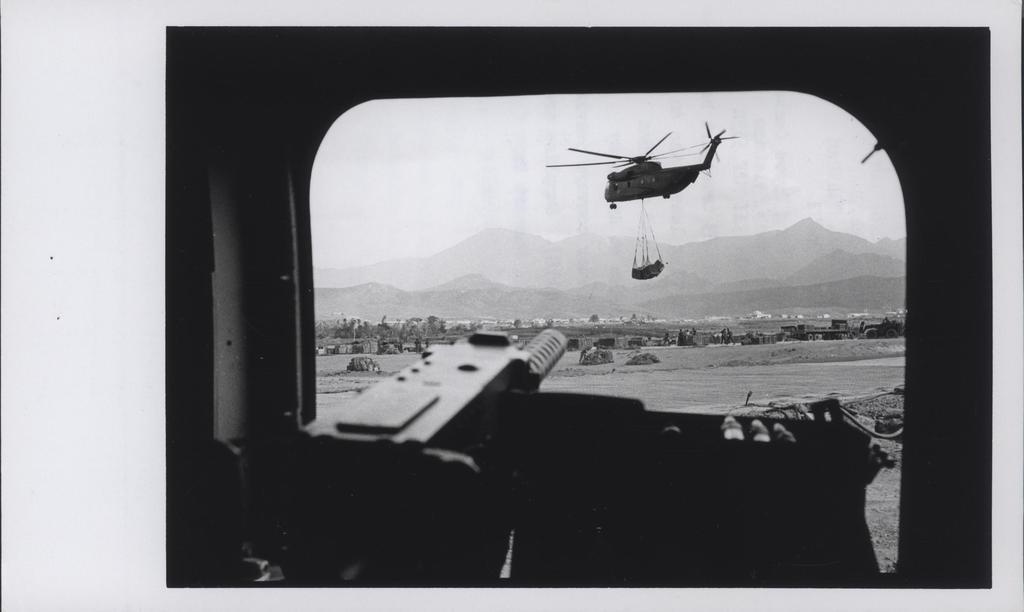Can you describe this image briefly? In this picture I can see a gun and in the background I can see a helicopter and hills and I can see few vehicles and trees. 